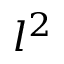<formula> <loc_0><loc_0><loc_500><loc_500>l ^ { 2 }</formula> 